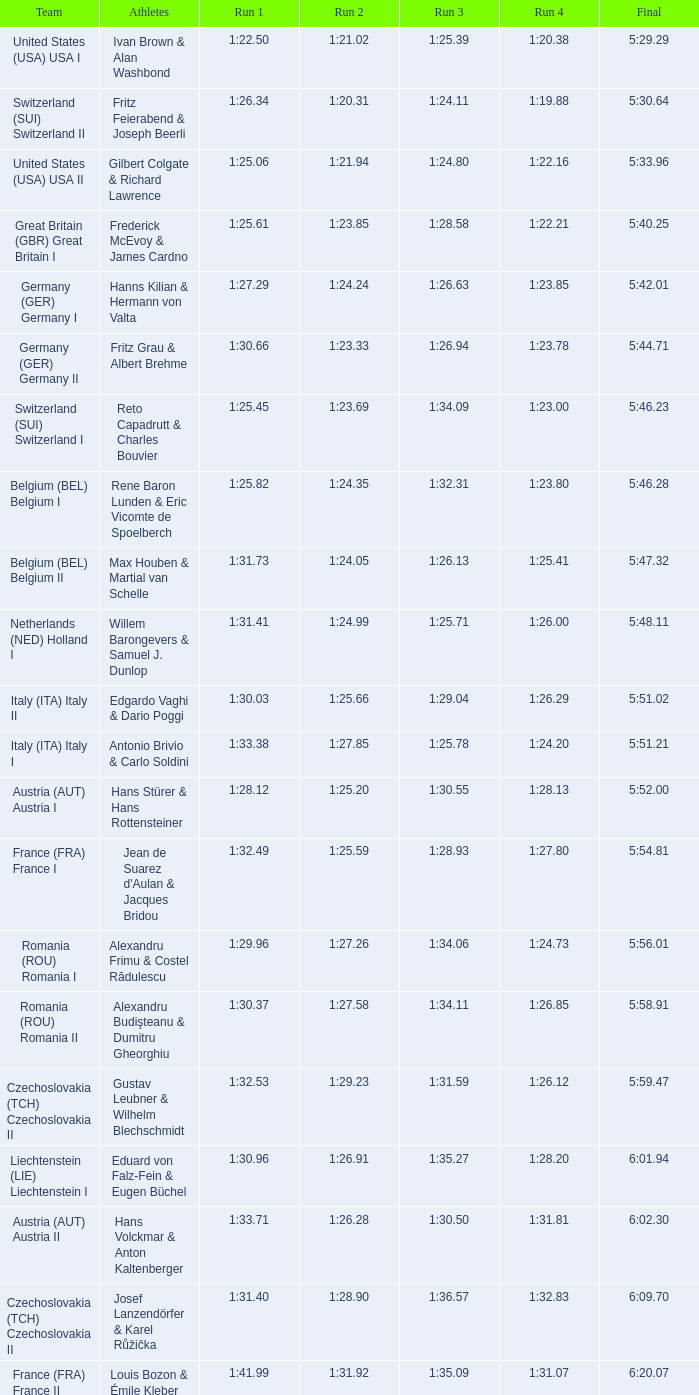Which run 4 possesses a run 3 duration of 1:2 1:23.85. 